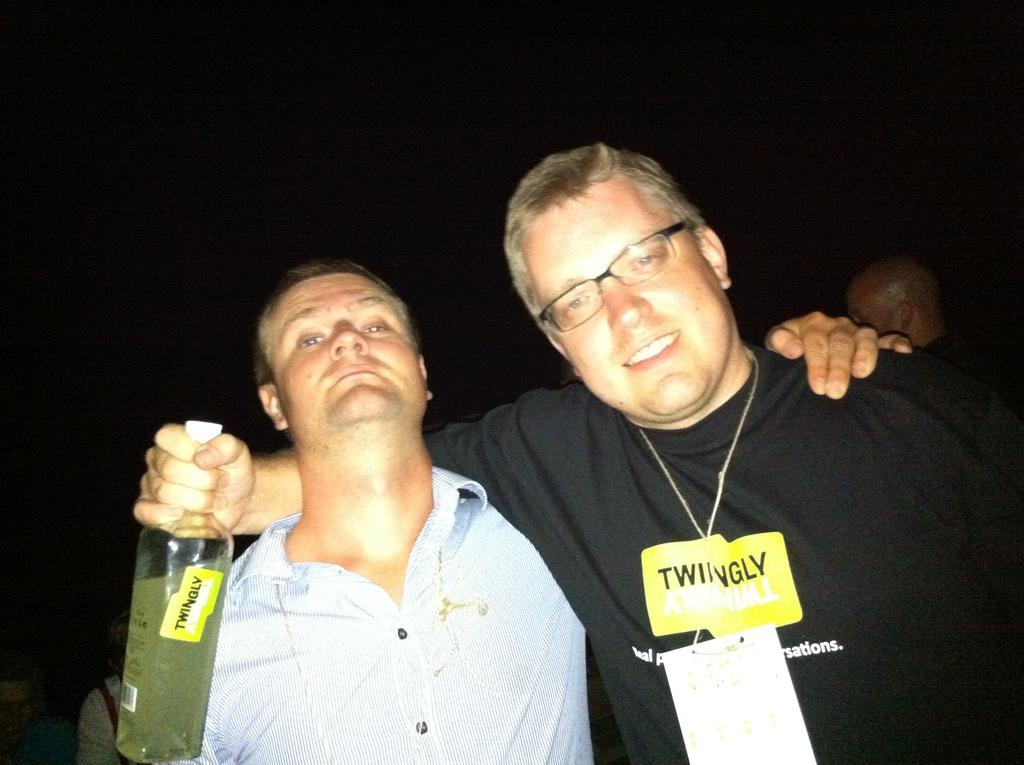How many people are in the image? There are two persons in the image. Can you describe their interaction? One person has their hand on the other person's shoulder. What is one person holding in the image? One person is holding a bottle. What accessory is worn by one of the persons? One person is wearing spectacles. What type of pen is visible in the image? There is no pen present in the image. How many stomachs can be seen in the image? There are no stomachs visible in the image. 